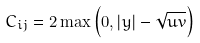<formula> <loc_0><loc_0><loc_500><loc_500>C _ { i j } = 2 \max \left ( 0 , \left | y \right | - \sqrt { u v } \right )</formula> 